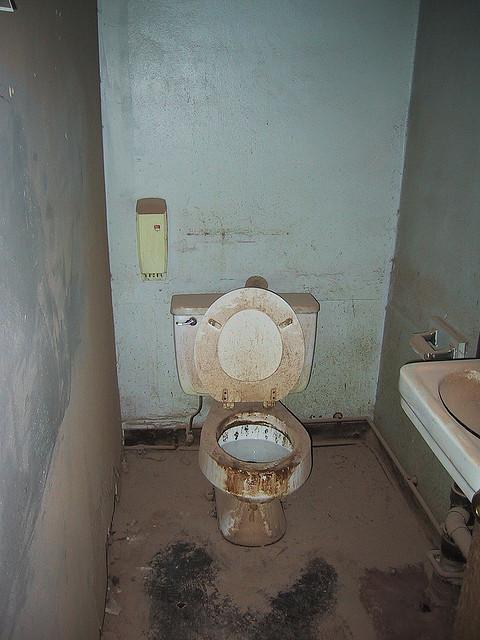How many toilets are there?
Give a very brief answer. 1. How many bowls have eggs?
Give a very brief answer. 0. 